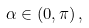<formula> <loc_0><loc_0><loc_500><loc_500>\alpha \in \left ( 0 , \pi \right ) ,</formula> 